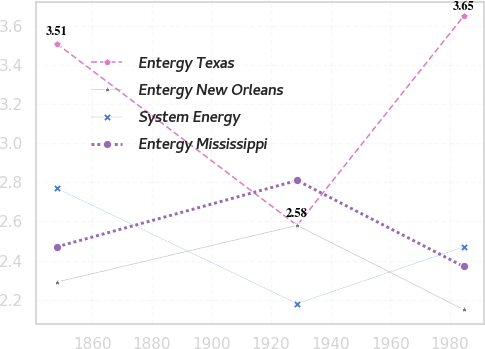<chart> <loc_0><loc_0><loc_500><loc_500><line_chart><ecel><fcel>Entergy Texas<fcel>Entergy New Orleans<fcel>System Energy<fcel>Entergy Mississippi<nl><fcel>1848.06<fcel>3.51<fcel>2.29<fcel>2.77<fcel>2.47<nl><fcel>1928.72<fcel>2.58<fcel>2.58<fcel>2.18<fcel>2.81<nl><fcel>1984.54<fcel>3.65<fcel>2.15<fcel>2.47<fcel>2.37<nl></chart> 